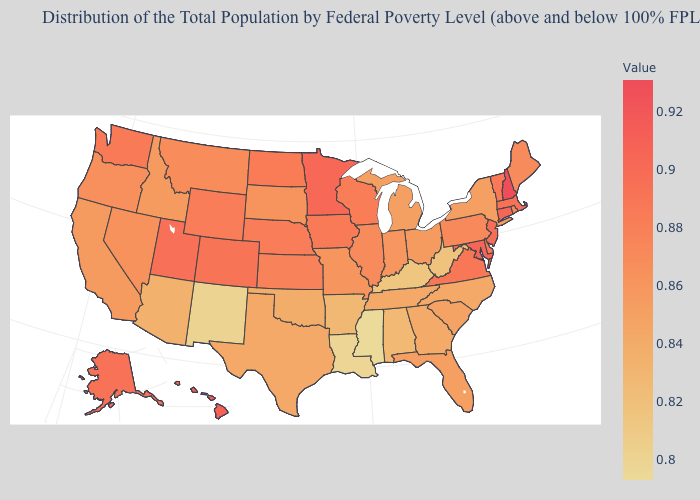Does New Hampshire have the highest value in the USA?
Quick response, please. Yes. Which states have the lowest value in the South?
Give a very brief answer. Mississippi. Which states hav the highest value in the West?
Answer briefly. Hawaii. Which states hav the highest value in the West?
Answer briefly. Hawaii. Among the states that border Wisconsin , does Michigan have the lowest value?
Give a very brief answer. Yes. 